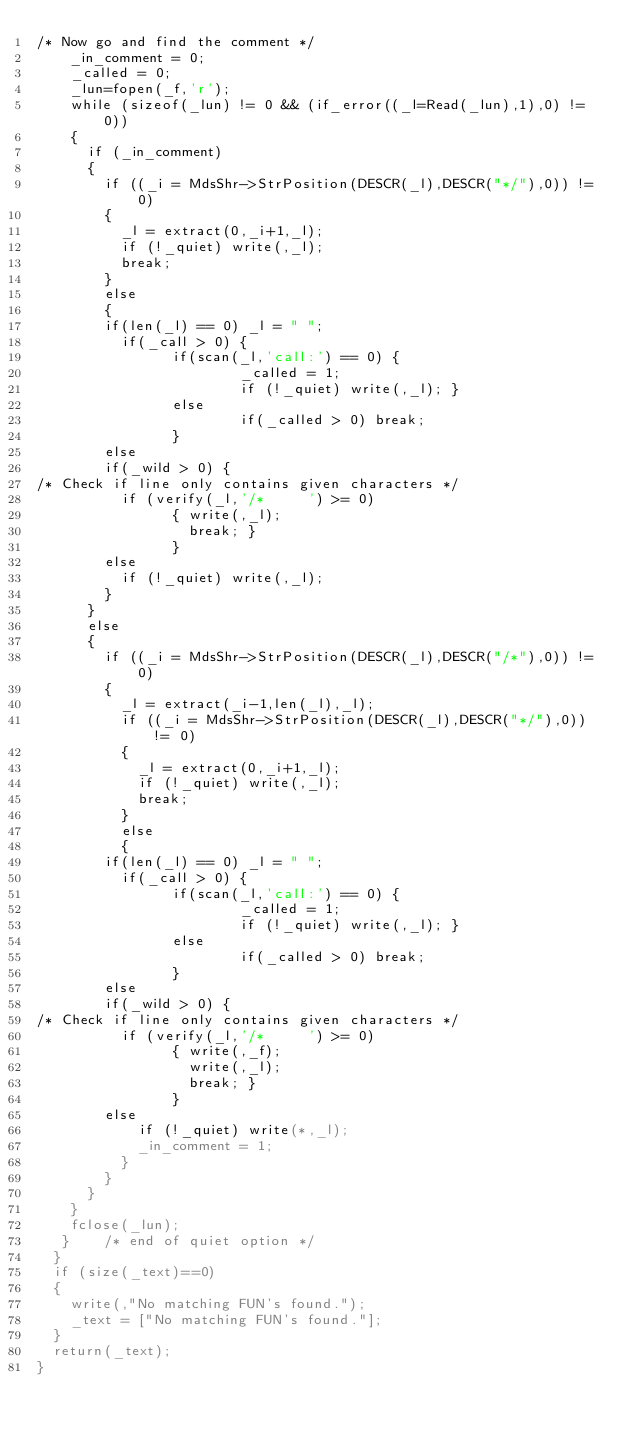Convert code to text. <code><loc_0><loc_0><loc_500><loc_500><_SML_>/* Now go and find the comment */
    _in_comment = 0;
    _called = 0;
    _lun=fopen(_f,'r');
    while (sizeof(_lun) != 0 && (if_error((_l=Read(_lun),1),0) != 0))
    {
      if (_in_comment)
      {
        if ((_i = MdsShr->StrPosition(DESCR(_l),DESCR("*/"),0)) != 0)
        {
          _l = extract(0,_i+1,_l);
          if (!_quiet) write(,_l);
          break;
        }
        else
        {
        if(len(_l) == 0) _l = " ";
          if(_call > 0) {
                if(scan(_l,'call:') == 0) {
                        _called = 1;
                        if (!_quiet) write(,_l); }
                else
                        if(_called > 0) break;
                }
        else
        if(_wild > 0) {
/* Check if line only contains given characters */
          if (verify(_l,'/*     ') >= 0)
                { write(,_l);
                  break; }
                }
        else
          if (!_quiet) write(,_l);
        }
      }
      else
      {
        if ((_i = MdsShr->StrPosition(DESCR(_l),DESCR("/*"),0)) != 0)
        {
          _l = extract(_i-1,len(_l),_l);
          if ((_i = MdsShr->StrPosition(DESCR(_l),DESCR("*/"),0)) != 0)
          {
            _l = extract(0,_i+1,_l);
            if (!_quiet) write(,_l);
            break;
          }
          else
          {
        if(len(_l) == 0) _l = " ";
          if(_call > 0) {
                if(scan(_l,'call:') == 0) {
                        _called = 1;
                        if (!_quiet) write(,_l); }
                else
                        if(_called > 0) break;
                }
        else
        if(_wild > 0) {
/* Check if line only contains given characters */
          if (verify(_l,'/*     ') >= 0)
                { write(,_f);
                  write(,_l);
                  break; }
                }
        else
            if (!_quiet) write(*,_l);
            _in_comment = 1;
          }
        }
      }
    }
    fclose(_lun);
   }    /* end of quiet option */
  }
  if (size(_text)==0) 
  {
    write(,"No matching FUN's found.");
    _text = ["No matching FUN's found."];
  }
  return(_text);
}</code> 